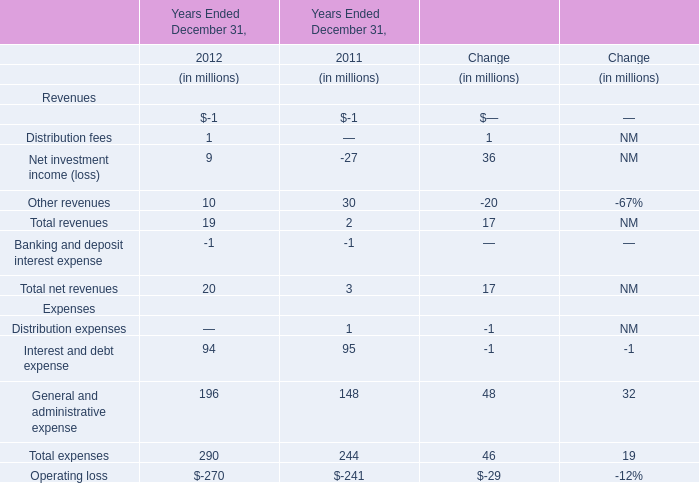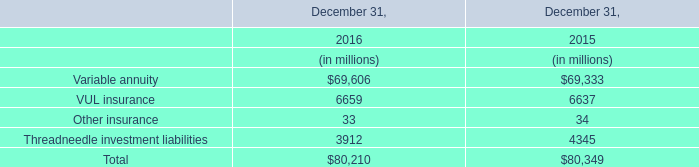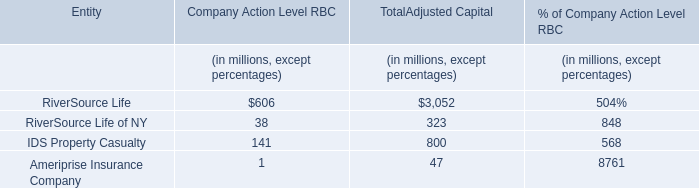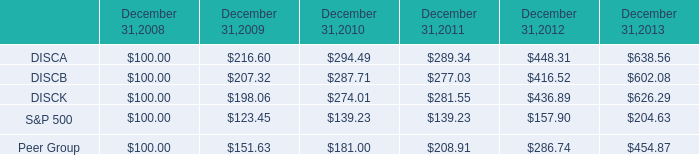What is the sum of IDS Property Casualty for TotalAdjusted Capital and VUL insurance in 2015? (in million) 
Computations: (800 + 6637)
Answer: 7437.0. 